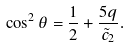Convert formula to latex. <formula><loc_0><loc_0><loc_500><loc_500>\cos ^ { 2 } \theta = \frac { 1 } { 2 } + \frac { 5 q } { \tilde { c } _ { 2 } } .</formula> 